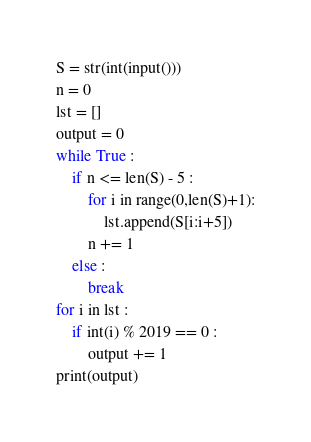<code> <loc_0><loc_0><loc_500><loc_500><_Python_>S = str(int(input()))
n = 0
lst = []
output = 0
while True :
    if n <= len(S) - 5 :
      	for i in range(0,len(S)+1):
        	lst.append(S[i:i+5])
        n += 1
    else :
        break
for i in lst :
    if int(i) % 2019 == 0 :
        output += 1
print(output)</code> 